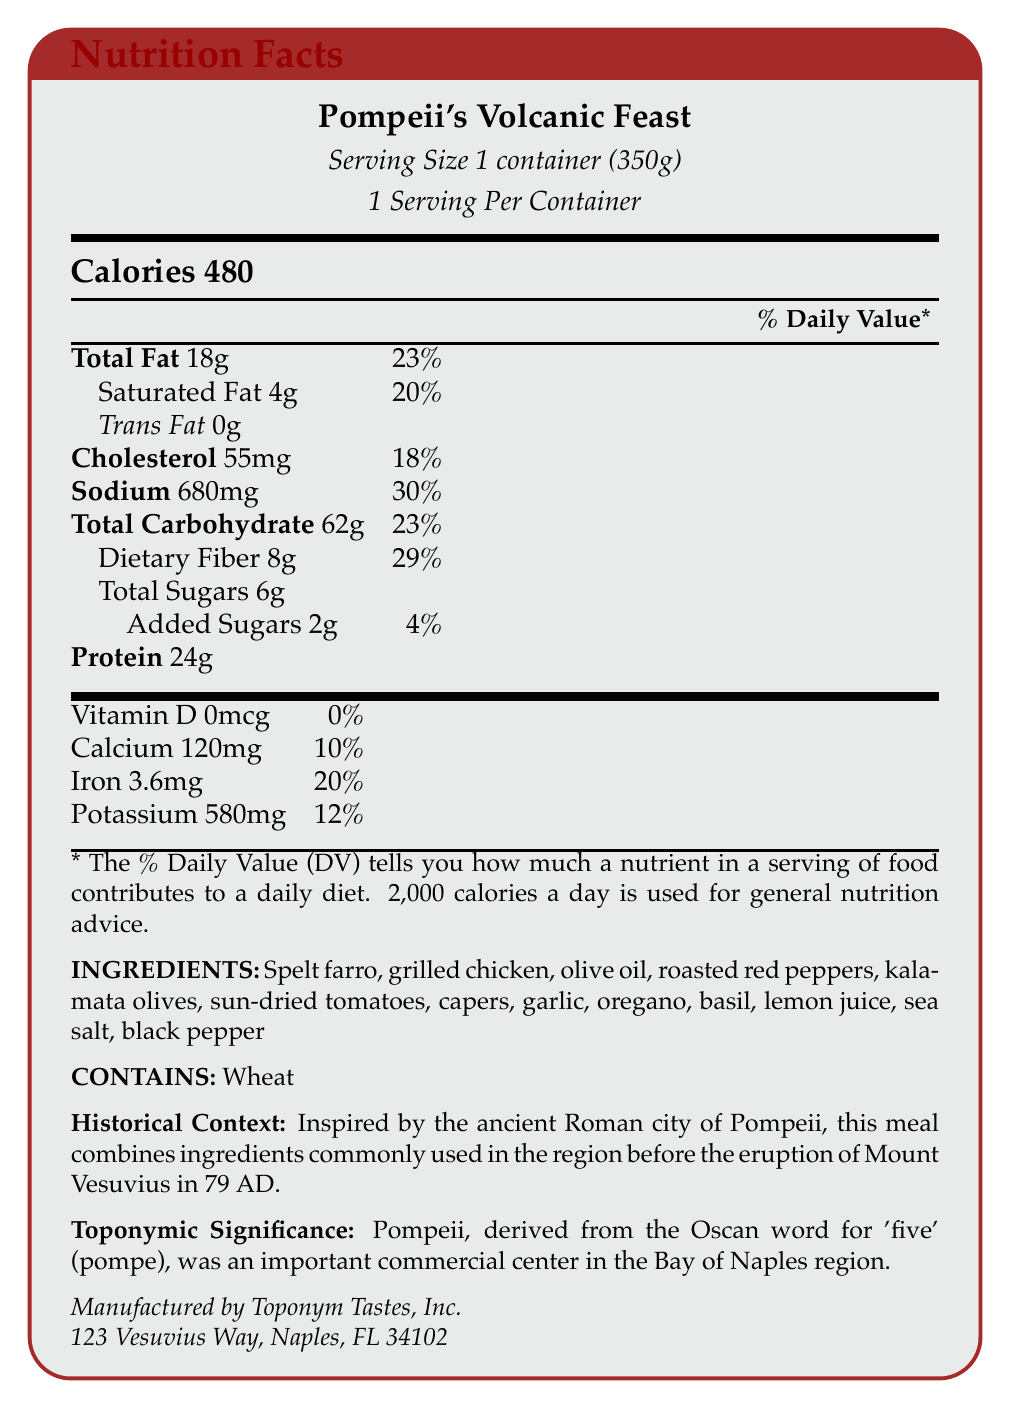what is the serving size? The serving size is explicitly mentioned at the beginning of the Nutrition Facts section.
Answer: 1 container (350g) how many servings are in the container? The label states that there is 1 serving per container.
Answer: 1 what is the total fat content per serving? The Nutrition Facts table specifies that the Total Fat content per serving is 18g.
Answer: 18g what percentage of the daily value is the sodium content? The sodium content's daily value is noted as 30% in the Nutrition Facts table.
Answer: 30% how many grams of dietary fiber are in the meal? The Nutrition Facts table indicates that there are 8g of dietary fiber per serving.
Answer: 8g which ingredient is listed first in the ingredients section? The first ingredient listed is Spelt farro.
Answer: Spelt farro what is the manufacturer’s address? The address of the manufacturer, Toponym Tastes, Inc., is given at the bottom of the document.
Answer: 123 Vesuvius Way, Naples, FL 34102 what historical event inspired this meal? The historical context section mentions that the meal is inspired by the ingredients commonly used in Pompeii before the eruption of Mount Vesuvius in 79 AD.
Answer: The eruption of Mount Vesuvius in 79 AD does the meal contain added sugars? The Nutrition Facts table lists 2g of added sugars, indicating that the meal does contain added sugars.
Answer: Yes how many calories are in one serving? The Nutrition Facts table mentions that there are 480 calories per serving.
Answer: 480 what is the olive content? A. 2g B. 4g C. Not specified D. 6g The exact amount of olives is not specified; ingredients are listed without individual quantities.
Answer: C which of the following nutrients has the highest daily value percentage? A. Dietary Fiber B. Sodium C. Total Carbohydrate D. Iron Dietary Fiber has a daily value percentage of 29%, which is higher than the percentages for Sodium (30%), Total Carbohydrate (23%), and Iron (20%).
Answer: A. Dietary Fiber does the document mention any allergens? The document states "Contains wheat" in the allergens section.
Answer: Yes what is the main idea of the document? The document includes nutritional facts, ingredient list, allergen information, historical context, and toponymic significance for "Pompeii's Volcanic Feast".
Answer: The document provides detailed nutritional information for the packaged meal "Pompeii's Volcanic Feast", which is inspired by ingredients from ancient Pompeii, alongside historical context and toponymic significance. how many milligrams of potassium are in the meal? The Nutrition Facts table lists the potassium content as 580mg per serving.
Answer: 580mg what is the total carbohydrate percentage of the daily value? The Nutrition Facts table lists the total carbohydrate daily value percentage as 23%.
Answer: 23% why is the product named 'Pompeii's Volcanic Feast'? The historical context explains that the meal is inspired by the ancient Roman city of Pompeii.
Answer: Inspired by the ancient Roman city of Pompeii, reflecting the use of regional ingredients before the eruption of Mount Vesuvius what is the capital of Italy? The document provides no information regarding the capital of Italy or any geographical information except for the historical context of Pompeii.
Answer: Not enough information 